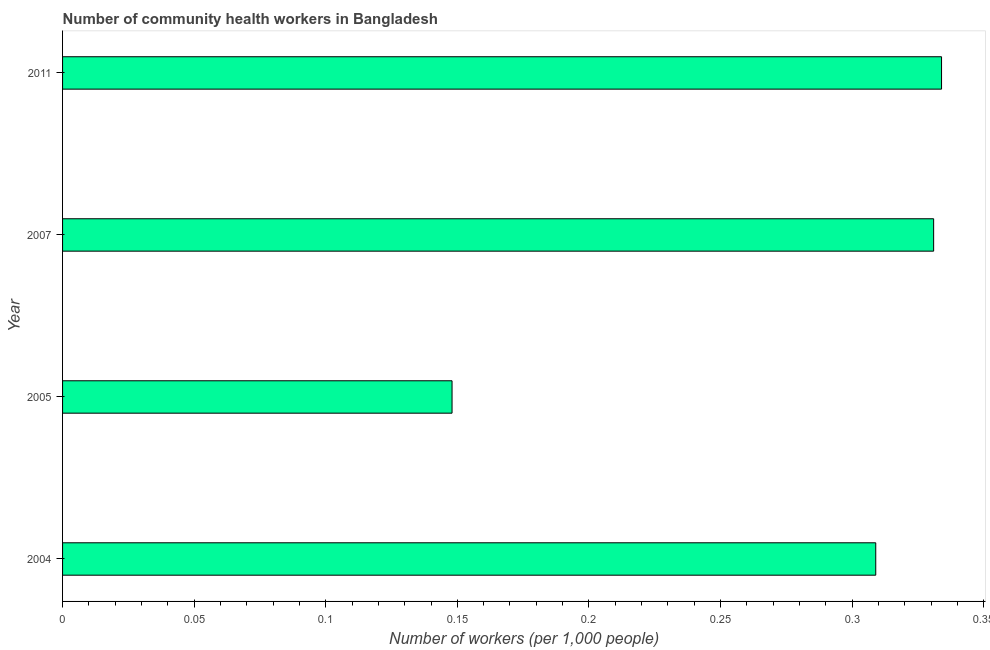Does the graph contain any zero values?
Offer a terse response. No. What is the title of the graph?
Your response must be concise. Number of community health workers in Bangladesh. What is the label or title of the X-axis?
Keep it short and to the point. Number of workers (per 1,0 people). What is the label or title of the Y-axis?
Provide a short and direct response. Year. What is the number of community health workers in 2004?
Make the answer very short. 0.31. Across all years, what is the maximum number of community health workers?
Offer a terse response. 0.33. Across all years, what is the minimum number of community health workers?
Your answer should be compact. 0.15. In which year was the number of community health workers minimum?
Offer a very short reply. 2005. What is the sum of the number of community health workers?
Your response must be concise. 1.12. What is the difference between the number of community health workers in 2005 and 2011?
Offer a very short reply. -0.19. What is the average number of community health workers per year?
Keep it short and to the point. 0.28. What is the median number of community health workers?
Make the answer very short. 0.32. What is the ratio of the number of community health workers in 2005 to that in 2007?
Keep it short and to the point. 0.45. Is the difference between the number of community health workers in 2004 and 2011 greater than the difference between any two years?
Keep it short and to the point. No. What is the difference between the highest and the second highest number of community health workers?
Your answer should be compact. 0. What is the difference between the highest and the lowest number of community health workers?
Provide a short and direct response. 0.19. In how many years, is the number of community health workers greater than the average number of community health workers taken over all years?
Give a very brief answer. 3. How many bars are there?
Offer a very short reply. 4. Are all the bars in the graph horizontal?
Keep it short and to the point. Yes. What is the difference between two consecutive major ticks on the X-axis?
Ensure brevity in your answer.  0.05. What is the Number of workers (per 1,000 people) in 2004?
Your answer should be compact. 0.31. What is the Number of workers (per 1,000 people) in 2005?
Keep it short and to the point. 0.15. What is the Number of workers (per 1,000 people) of 2007?
Provide a succinct answer. 0.33. What is the Number of workers (per 1,000 people) of 2011?
Ensure brevity in your answer.  0.33. What is the difference between the Number of workers (per 1,000 people) in 2004 and 2005?
Provide a succinct answer. 0.16. What is the difference between the Number of workers (per 1,000 people) in 2004 and 2007?
Offer a terse response. -0.02. What is the difference between the Number of workers (per 1,000 people) in 2004 and 2011?
Offer a very short reply. -0.03. What is the difference between the Number of workers (per 1,000 people) in 2005 and 2007?
Keep it short and to the point. -0.18. What is the difference between the Number of workers (per 1,000 people) in 2005 and 2011?
Provide a succinct answer. -0.19. What is the difference between the Number of workers (per 1,000 people) in 2007 and 2011?
Provide a short and direct response. -0. What is the ratio of the Number of workers (per 1,000 people) in 2004 to that in 2005?
Provide a short and direct response. 2.09. What is the ratio of the Number of workers (per 1,000 people) in 2004 to that in 2007?
Provide a succinct answer. 0.93. What is the ratio of the Number of workers (per 1,000 people) in 2004 to that in 2011?
Provide a succinct answer. 0.93. What is the ratio of the Number of workers (per 1,000 people) in 2005 to that in 2007?
Provide a succinct answer. 0.45. What is the ratio of the Number of workers (per 1,000 people) in 2005 to that in 2011?
Keep it short and to the point. 0.44. 